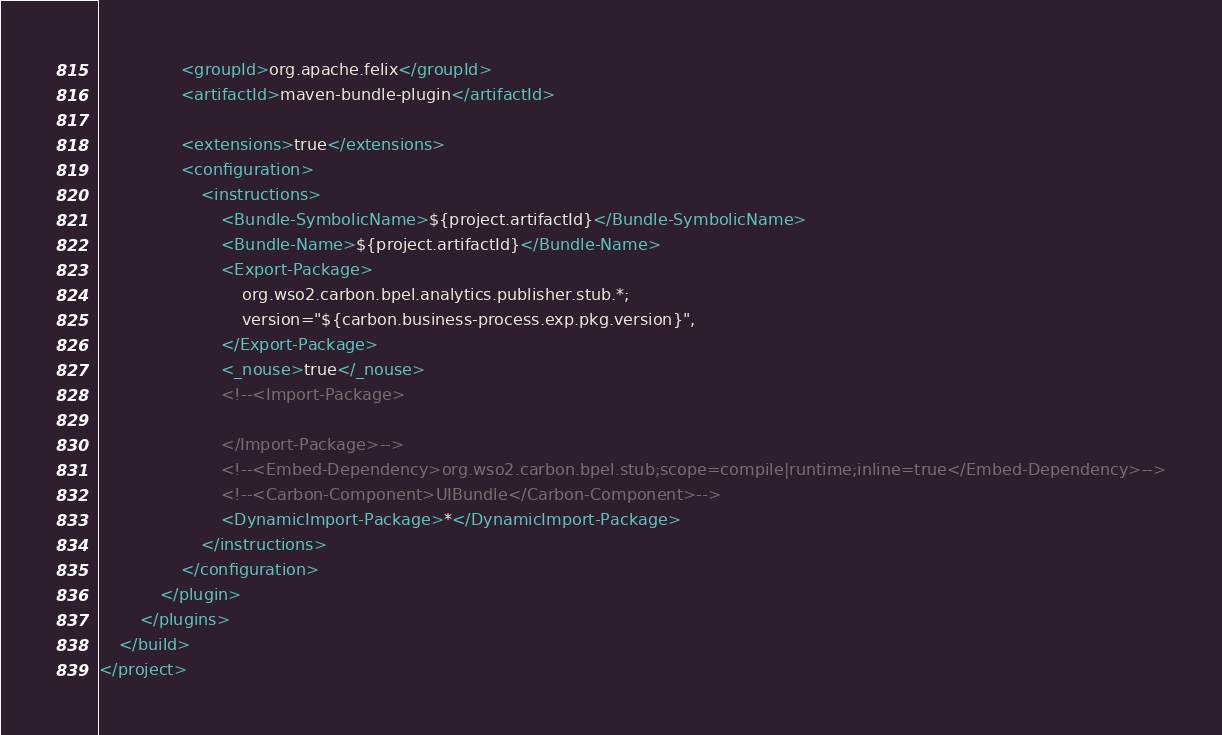<code> <loc_0><loc_0><loc_500><loc_500><_XML_>                <groupId>org.apache.felix</groupId>
                <artifactId>maven-bundle-plugin</artifactId>

                <extensions>true</extensions>
                <configuration>
                    <instructions>
                        <Bundle-SymbolicName>${project.artifactId}</Bundle-SymbolicName>
                        <Bundle-Name>${project.artifactId}</Bundle-Name>
                        <Export-Package>
                            org.wso2.carbon.bpel.analytics.publisher.stub.*;
                            version="${carbon.business-process.exp.pkg.version}",
                        </Export-Package>
                        <_nouse>true</_nouse>
                        <!--<Import-Package>

                        </Import-Package>-->
                        <!--<Embed-Dependency>org.wso2.carbon.bpel.stub;scope=compile|runtime;inline=true</Embed-Dependency>-->
                        <!--<Carbon-Component>UIBundle</Carbon-Component>-->
                        <DynamicImport-Package>*</DynamicImport-Package>
                    </instructions>
                </configuration>
            </plugin>
        </plugins>
    </build>
</project>
</code> 